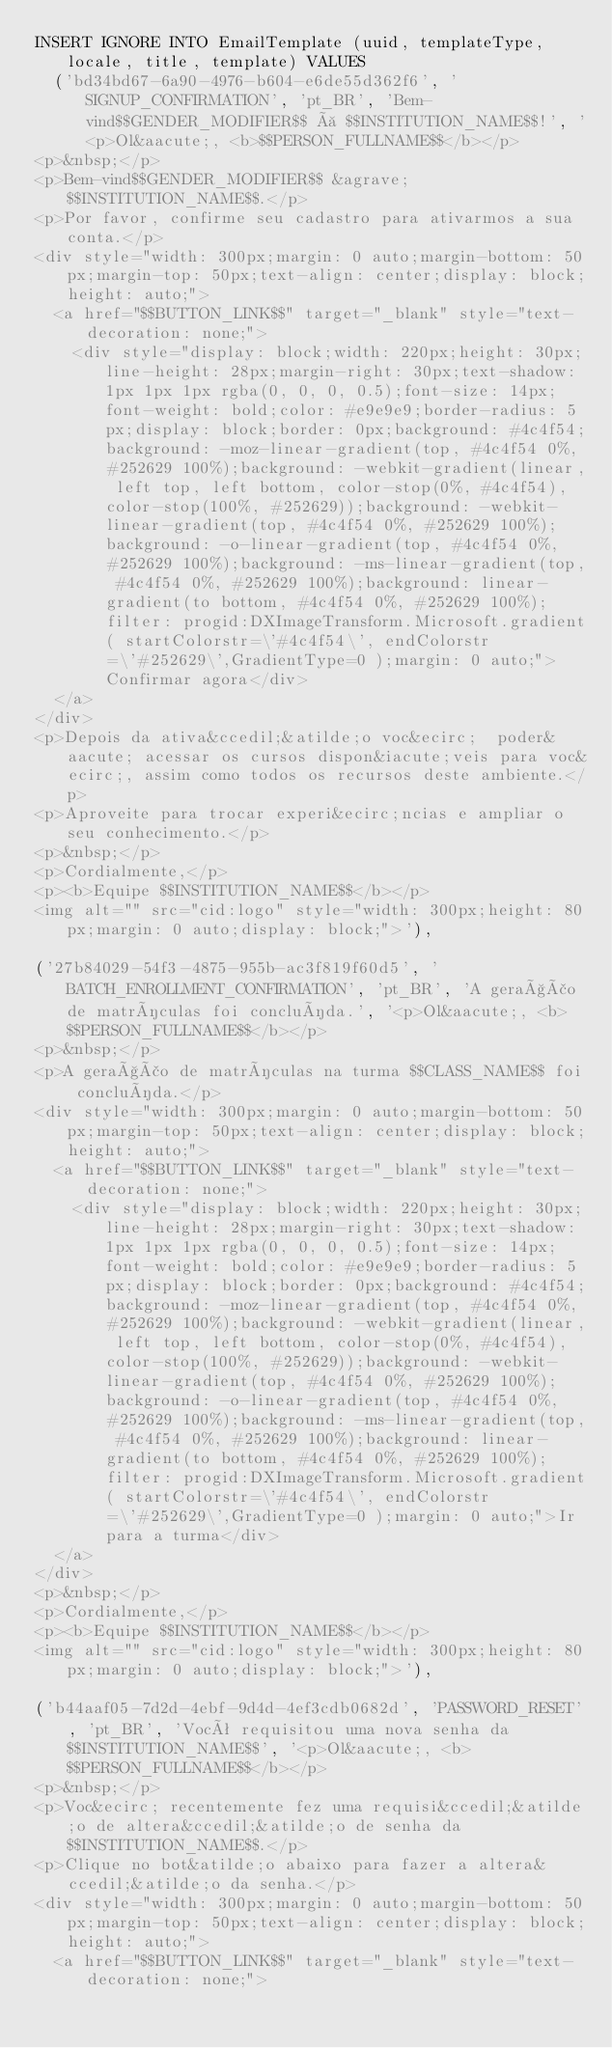<code> <loc_0><loc_0><loc_500><loc_500><_SQL_>INSERT IGNORE INTO EmailTemplate (uuid, templateType, locale, title, template) VALUES
	('bd34bd67-6a90-4976-b604-e6de55d362f6', 'SIGNUP_CONFIRMATION', 'pt_BR', 'Bem-vind$$GENDER_MODIFIER$$ à $$INSTITUTION_NAME$$!', '<p>Ol&aacute;, <b>$$PERSON_FULLNAME$$</b></p>
<p>&nbsp;</p>
<p>Bem-vind$$GENDER_MODIFIER$$ &agrave; $$INSTITUTION_NAME$$.</p>
<p>Por favor, confirme seu cadastro para ativarmos a sua conta.</p>
<div style="width: 300px;margin: 0 auto;margin-bottom: 50px;margin-top: 50px;text-align: center;display: block;height: auto;">
	<a href="$$BUTTON_LINK$$" target="_blank" style="text-decoration: none;">
		<div style="display: block;width: 220px;height: 30px;line-height: 28px;margin-right: 30px;text-shadow: 1px 1px 1px rgba(0, 0, 0, 0.5);font-size: 14px;font-weight: bold;color: #e9e9e9;border-radius: 5px;display: block;border: 0px;background: #4c4f54;background: -moz-linear-gradient(top, #4c4f54 0%, #252629 100%);background: -webkit-gradient(linear, left top, left bottom, color-stop(0%, #4c4f54), color-stop(100%, #252629));background: -webkit-linear-gradient(top, #4c4f54 0%, #252629 100%);background: -o-linear-gradient(top, #4c4f54 0%, #252629 100%);background: -ms-linear-gradient(top, #4c4f54 0%, #252629 100%);background: linear-gradient(to bottom, #4c4f54 0%, #252629 100%);filter: progid:DXImageTransform.Microsoft.gradient( startColorstr=\'#4c4f54\', endColorstr=\'#252629\',GradientType=0 );margin: 0 auto;">Confirmar agora</div>
	</a>
</div>
<p>Depois da ativa&ccedil;&atilde;o voc&ecirc;  poder&aacute; acessar os cursos dispon&iacute;veis para voc&ecirc;, assim como todos os recursos deste ambiente.</p>
<p>Aproveite para trocar experi&ecirc;ncias e ampliar o seu conhecimento.</p>
<p>&nbsp;</p>
<p>Cordialmente,</p>
<p><b>Equipe $$INSTITUTION_NAME$$</b></p>
<img alt="" src="cid:logo" style="width: 300px;height: 80px;margin: 0 auto;display: block;">'),

('27b84029-54f3-4875-955b-ac3f819f60d5', 'BATCH_ENROLLMENT_CONFIRMATION', 'pt_BR', 'A geração de matrículas foi concluída.', '<p>Ol&aacute;, <b>$$PERSON_FULLNAME$$</b></p>
<p>&nbsp;</p>
<p>A geração de matrículas na turma $$CLASS_NAME$$ foi concluída.</p>
<div style="width: 300px;margin: 0 auto;margin-bottom: 50px;margin-top: 50px;text-align: center;display: block;height: auto;">
	<a href="$$BUTTON_LINK$$" target="_blank" style="text-decoration: none;">
		<div style="display: block;width: 220px;height: 30px;line-height: 28px;margin-right: 30px;text-shadow: 1px 1px 1px rgba(0, 0, 0, 0.5);font-size: 14px;font-weight: bold;color: #e9e9e9;border-radius: 5px;display: block;border: 0px;background: #4c4f54;background: -moz-linear-gradient(top, #4c4f54 0%, #252629 100%);background: -webkit-gradient(linear, left top, left bottom, color-stop(0%, #4c4f54), color-stop(100%, #252629));background: -webkit-linear-gradient(top, #4c4f54 0%, #252629 100%);background: -o-linear-gradient(top, #4c4f54 0%, #252629 100%);background: -ms-linear-gradient(top, #4c4f54 0%, #252629 100%);background: linear-gradient(to bottom, #4c4f54 0%, #252629 100%);filter: progid:DXImageTransform.Microsoft.gradient( startColorstr=\'#4c4f54\', endColorstr=\'#252629\',GradientType=0 );margin: 0 auto;">Ir para a turma</div>
	</a>
</div>
<p>&nbsp;</p>
<p>Cordialmente,</p>
<p><b>Equipe $$INSTITUTION_NAME$$</b></p>
<img alt="" src="cid:logo" style="width: 300px;height: 80px;margin: 0 auto;display: block;">'),

('b44aaf05-7d2d-4ebf-9d4d-4ef3cdb0682d', 'PASSWORD_RESET', 'pt_BR', 'Você requisitou uma nova senha da $$INSTITUTION_NAME$$', '<p>Ol&aacute;, <b>$$PERSON_FULLNAME$$</b></p>
<p>&nbsp;</p>
<p>Voc&ecirc; recentemente fez uma requisi&ccedil;&atilde;o de altera&ccedil;&atilde;o de senha da $$INSTITUTION_NAME$$.</p>
<p>Clique no bot&atilde;o abaixo para fazer a altera&ccedil;&atilde;o da senha.</p>
<div style="width: 300px;margin: 0 auto;margin-bottom: 50px;margin-top: 50px;text-align: center;display: block;height: auto;">
	<a href="$$BUTTON_LINK$$" target="_blank" style="text-decoration: none;"></code> 